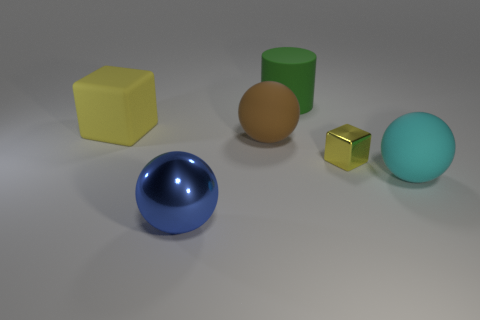Compared to the other objects, how would you describe the size of the blue sphere? The blue sphere is approximately medium-sized when compared to the other objects. It's larger than both the golden cube and the brown hemisphere but smaller than the yellow cube and green cylinder. 